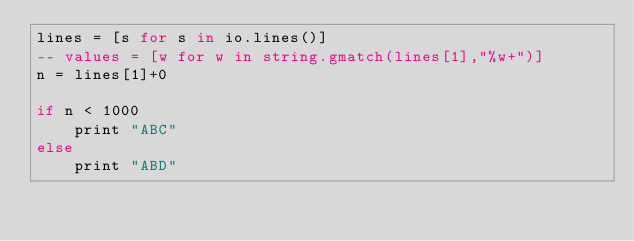Convert code to text. <code><loc_0><loc_0><loc_500><loc_500><_MoonScript_>lines = [s for s in io.lines()]
-- values = [w for w in string.gmatch(lines[1],"%w+")]
n = lines[1]+0

if n < 1000
	print "ABC"
else
	print "ABD"
</code> 